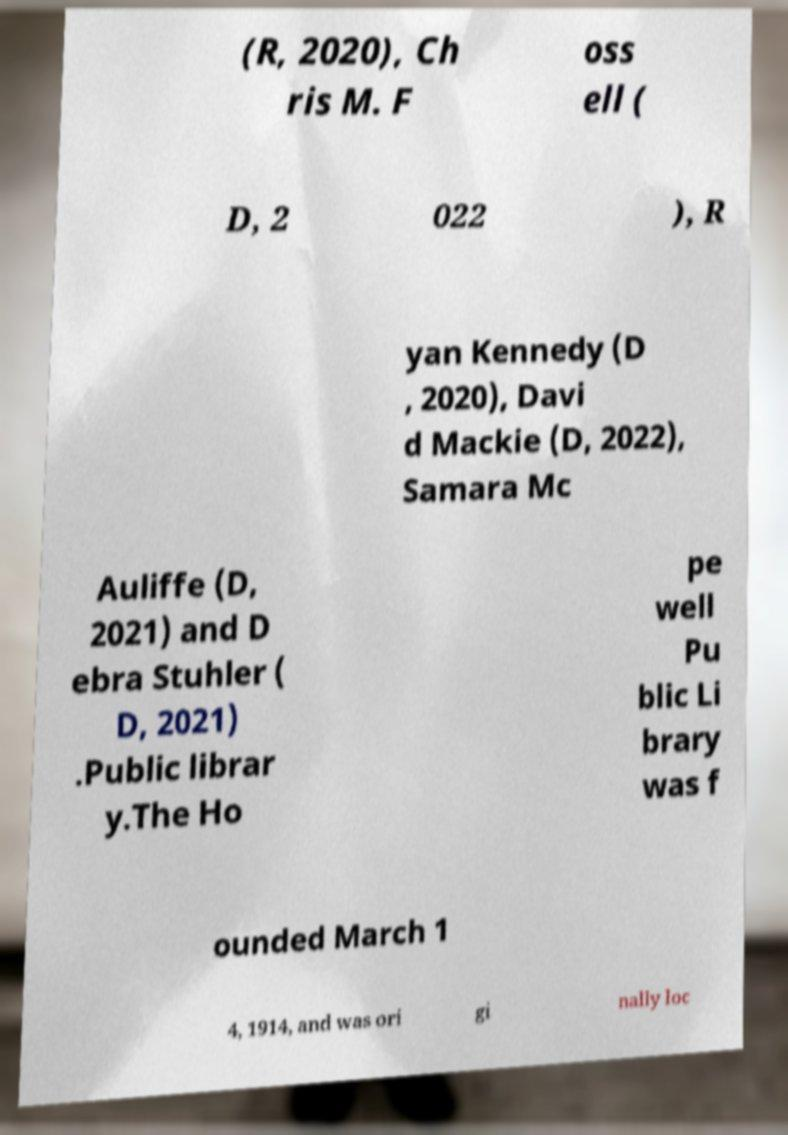Can you accurately transcribe the text from the provided image for me? (R, 2020), Ch ris M. F oss ell ( D, 2 022 ), R yan Kennedy (D , 2020), Davi d Mackie (D, 2022), Samara Mc Auliffe (D, 2021) and D ebra Stuhler ( D, 2021) .Public librar y.The Ho pe well Pu blic Li brary was f ounded March 1 4, 1914, and was ori gi nally loc 